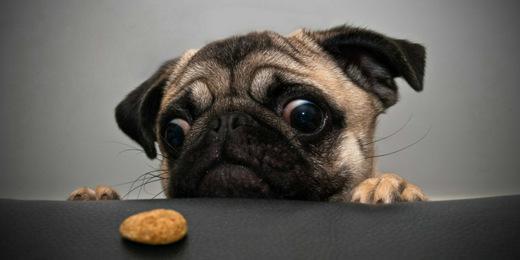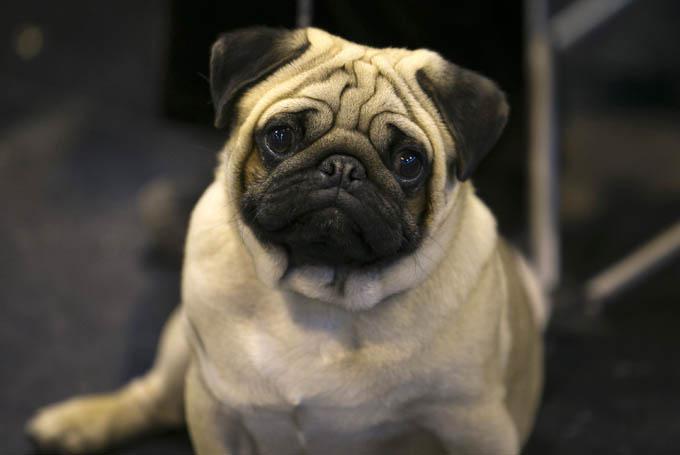The first image is the image on the left, the second image is the image on the right. For the images shown, is this caption "One of the dogs is sitting on the grass." true? Answer yes or no. No. 